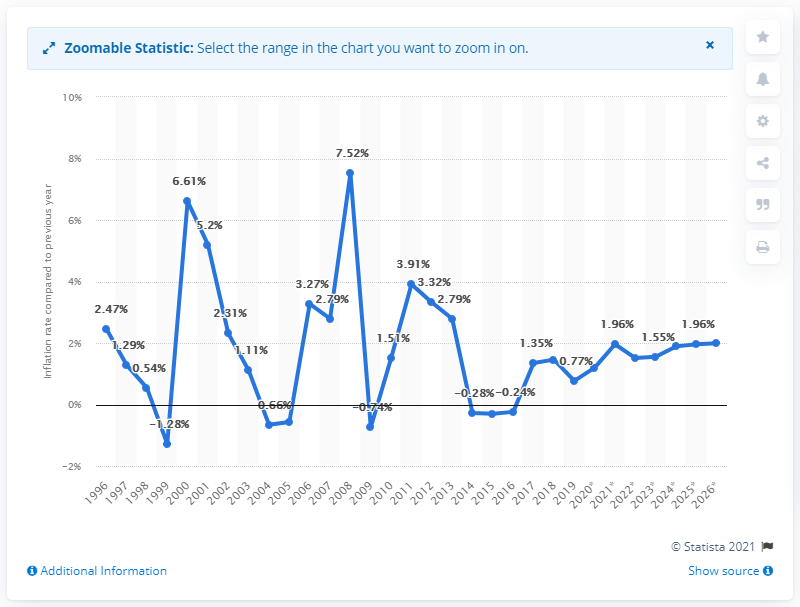Point out several critical features in this image. In 1996, the average inflation rate in North Macedonia was X. 